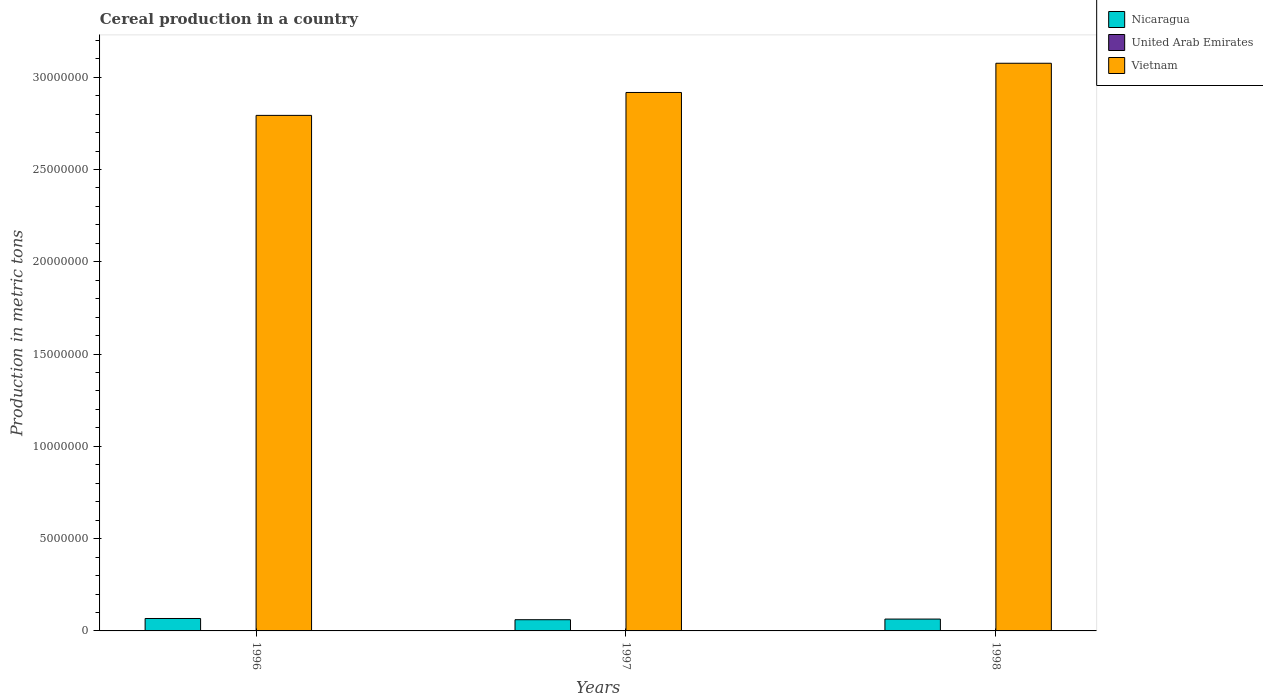How many different coloured bars are there?
Ensure brevity in your answer.  3. How many groups of bars are there?
Give a very brief answer. 3. Are the number of bars per tick equal to the number of legend labels?
Ensure brevity in your answer.  Yes. How many bars are there on the 3rd tick from the left?
Provide a succinct answer. 3. What is the label of the 2nd group of bars from the left?
Your answer should be very brief. 1997. In how many cases, is the number of bars for a given year not equal to the number of legend labels?
Your response must be concise. 0. What is the total cereal production in Vietnam in 1997?
Make the answer very short. 2.92e+07. Across all years, what is the maximum total cereal production in Nicaragua?
Make the answer very short. 6.74e+05. Across all years, what is the minimum total cereal production in Vietnam?
Offer a terse response. 2.79e+07. In which year was the total cereal production in Nicaragua maximum?
Ensure brevity in your answer.  1996. In which year was the total cereal production in United Arab Emirates minimum?
Your answer should be very brief. 1997. What is the total total cereal production in Vietnam in the graph?
Offer a very short reply. 8.79e+07. What is the difference between the total cereal production in United Arab Emirates in 1996 and that in 1997?
Your answer should be very brief. 303. What is the difference between the total cereal production in Nicaragua in 1998 and the total cereal production in United Arab Emirates in 1996?
Your answer should be compact. 6.42e+05. What is the average total cereal production in United Arab Emirates per year?
Give a very brief answer. 419.67. In the year 1998, what is the difference between the total cereal production in United Arab Emirates and total cereal production in Nicaragua?
Give a very brief answer. -6.42e+05. In how many years, is the total cereal production in Nicaragua greater than 13000000 metric tons?
Provide a short and direct response. 0. What is the ratio of the total cereal production in Vietnam in 1996 to that in 1998?
Provide a succinct answer. 0.91. Is the total cereal production in Nicaragua in 1996 less than that in 1998?
Provide a succinct answer. No. What is the difference between the highest and the second highest total cereal production in Nicaragua?
Your answer should be very brief. 3.17e+04. What is the difference between the highest and the lowest total cereal production in United Arab Emirates?
Make the answer very short. 303. Is the sum of the total cereal production in Nicaragua in 1996 and 1997 greater than the maximum total cereal production in United Arab Emirates across all years?
Offer a very short reply. Yes. What does the 2nd bar from the left in 1997 represents?
Provide a succinct answer. United Arab Emirates. What does the 3rd bar from the right in 1997 represents?
Make the answer very short. Nicaragua. Where does the legend appear in the graph?
Offer a terse response. Top right. What is the title of the graph?
Offer a terse response. Cereal production in a country. What is the label or title of the Y-axis?
Make the answer very short. Production in metric tons. What is the Production in metric tons in Nicaragua in 1996?
Your response must be concise. 6.74e+05. What is the Production in metric tons of United Arab Emirates in 1996?
Ensure brevity in your answer.  601. What is the Production in metric tons in Vietnam in 1996?
Offer a very short reply. 2.79e+07. What is the Production in metric tons in Nicaragua in 1997?
Keep it short and to the point. 6.08e+05. What is the Production in metric tons in United Arab Emirates in 1997?
Ensure brevity in your answer.  298. What is the Production in metric tons of Vietnam in 1997?
Make the answer very short. 2.92e+07. What is the Production in metric tons of Nicaragua in 1998?
Provide a short and direct response. 6.42e+05. What is the Production in metric tons in United Arab Emirates in 1998?
Keep it short and to the point. 360. What is the Production in metric tons of Vietnam in 1998?
Your answer should be very brief. 3.08e+07. Across all years, what is the maximum Production in metric tons in Nicaragua?
Ensure brevity in your answer.  6.74e+05. Across all years, what is the maximum Production in metric tons of United Arab Emirates?
Make the answer very short. 601. Across all years, what is the maximum Production in metric tons of Vietnam?
Make the answer very short. 3.08e+07. Across all years, what is the minimum Production in metric tons in Nicaragua?
Your response must be concise. 6.08e+05. Across all years, what is the minimum Production in metric tons in United Arab Emirates?
Offer a very short reply. 298. Across all years, what is the minimum Production in metric tons in Vietnam?
Provide a short and direct response. 2.79e+07. What is the total Production in metric tons in Nicaragua in the graph?
Give a very brief answer. 1.92e+06. What is the total Production in metric tons in United Arab Emirates in the graph?
Provide a succinct answer. 1259. What is the total Production in metric tons of Vietnam in the graph?
Offer a very short reply. 8.79e+07. What is the difference between the Production in metric tons in Nicaragua in 1996 and that in 1997?
Give a very brief answer. 6.63e+04. What is the difference between the Production in metric tons in United Arab Emirates in 1996 and that in 1997?
Offer a very short reply. 303. What is the difference between the Production in metric tons in Vietnam in 1996 and that in 1997?
Make the answer very short. -1.24e+06. What is the difference between the Production in metric tons in Nicaragua in 1996 and that in 1998?
Keep it short and to the point. 3.17e+04. What is the difference between the Production in metric tons in United Arab Emirates in 1996 and that in 1998?
Ensure brevity in your answer.  241. What is the difference between the Production in metric tons of Vietnam in 1996 and that in 1998?
Keep it short and to the point. -2.82e+06. What is the difference between the Production in metric tons of Nicaragua in 1997 and that in 1998?
Your answer should be very brief. -3.45e+04. What is the difference between the Production in metric tons of United Arab Emirates in 1997 and that in 1998?
Give a very brief answer. -62. What is the difference between the Production in metric tons of Vietnam in 1997 and that in 1998?
Offer a terse response. -1.58e+06. What is the difference between the Production in metric tons in Nicaragua in 1996 and the Production in metric tons in United Arab Emirates in 1997?
Your answer should be compact. 6.74e+05. What is the difference between the Production in metric tons in Nicaragua in 1996 and the Production in metric tons in Vietnam in 1997?
Your response must be concise. -2.85e+07. What is the difference between the Production in metric tons in United Arab Emirates in 1996 and the Production in metric tons in Vietnam in 1997?
Ensure brevity in your answer.  -2.92e+07. What is the difference between the Production in metric tons of Nicaragua in 1996 and the Production in metric tons of United Arab Emirates in 1998?
Offer a very short reply. 6.73e+05. What is the difference between the Production in metric tons in Nicaragua in 1996 and the Production in metric tons in Vietnam in 1998?
Make the answer very short. -3.01e+07. What is the difference between the Production in metric tons of United Arab Emirates in 1996 and the Production in metric tons of Vietnam in 1998?
Provide a succinct answer. -3.08e+07. What is the difference between the Production in metric tons in Nicaragua in 1997 and the Production in metric tons in United Arab Emirates in 1998?
Offer a terse response. 6.07e+05. What is the difference between the Production in metric tons of Nicaragua in 1997 and the Production in metric tons of Vietnam in 1998?
Your answer should be very brief. -3.01e+07. What is the difference between the Production in metric tons in United Arab Emirates in 1997 and the Production in metric tons in Vietnam in 1998?
Ensure brevity in your answer.  -3.08e+07. What is the average Production in metric tons in Nicaragua per year?
Your response must be concise. 6.41e+05. What is the average Production in metric tons of United Arab Emirates per year?
Make the answer very short. 419.67. What is the average Production in metric tons of Vietnam per year?
Your answer should be very brief. 2.93e+07. In the year 1996, what is the difference between the Production in metric tons in Nicaragua and Production in metric tons in United Arab Emirates?
Keep it short and to the point. 6.73e+05. In the year 1996, what is the difference between the Production in metric tons in Nicaragua and Production in metric tons in Vietnam?
Provide a short and direct response. -2.73e+07. In the year 1996, what is the difference between the Production in metric tons of United Arab Emirates and Production in metric tons of Vietnam?
Give a very brief answer. -2.79e+07. In the year 1997, what is the difference between the Production in metric tons in Nicaragua and Production in metric tons in United Arab Emirates?
Keep it short and to the point. 6.07e+05. In the year 1997, what is the difference between the Production in metric tons in Nicaragua and Production in metric tons in Vietnam?
Provide a short and direct response. -2.86e+07. In the year 1997, what is the difference between the Production in metric tons of United Arab Emirates and Production in metric tons of Vietnam?
Your answer should be very brief. -2.92e+07. In the year 1998, what is the difference between the Production in metric tons in Nicaragua and Production in metric tons in United Arab Emirates?
Offer a very short reply. 6.42e+05. In the year 1998, what is the difference between the Production in metric tons of Nicaragua and Production in metric tons of Vietnam?
Offer a very short reply. -3.01e+07. In the year 1998, what is the difference between the Production in metric tons of United Arab Emirates and Production in metric tons of Vietnam?
Make the answer very short. -3.08e+07. What is the ratio of the Production in metric tons of Nicaragua in 1996 to that in 1997?
Offer a terse response. 1.11. What is the ratio of the Production in metric tons in United Arab Emirates in 1996 to that in 1997?
Provide a short and direct response. 2.02. What is the ratio of the Production in metric tons of Vietnam in 1996 to that in 1997?
Offer a terse response. 0.96. What is the ratio of the Production in metric tons in Nicaragua in 1996 to that in 1998?
Your response must be concise. 1.05. What is the ratio of the Production in metric tons of United Arab Emirates in 1996 to that in 1998?
Your answer should be compact. 1.67. What is the ratio of the Production in metric tons in Vietnam in 1996 to that in 1998?
Give a very brief answer. 0.91. What is the ratio of the Production in metric tons in Nicaragua in 1997 to that in 1998?
Make the answer very short. 0.95. What is the ratio of the Production in metric tons in United Arab Emirates in 1997 to that in 1998?
Your answer should be compact. 0.83. What is the ratio of the Production in metric tons in Vietnam in 1997 to that in 1998?
Ensure brevity in your answer.  0.95. What is the difference between the highest and the second highest Production in metric tons in Nicaragua?
Your answer should be compact. 3.17e+04. What is the difference between the highest and the second highest Production in metric tons of United Arab Emirates?
Provide a succinct answer. 241. What is the difference between the highest and the second highest Production in metric tons in Vietnam?
Offer a very short reply. 1.58e+06. What is the difference between the highest and the lowest Production in metric tons in Nicaragua?
Provide a short and direct response. 6.63e+04. What is the difference between the highest and the lowest Production in metric tons in United Arab Emirates?
Your response must be concise. 303. What is the difference between the highest and the lowest Production in metric tons in Vietnam?
Ensure brevity in your answer.  2.82e+06. 